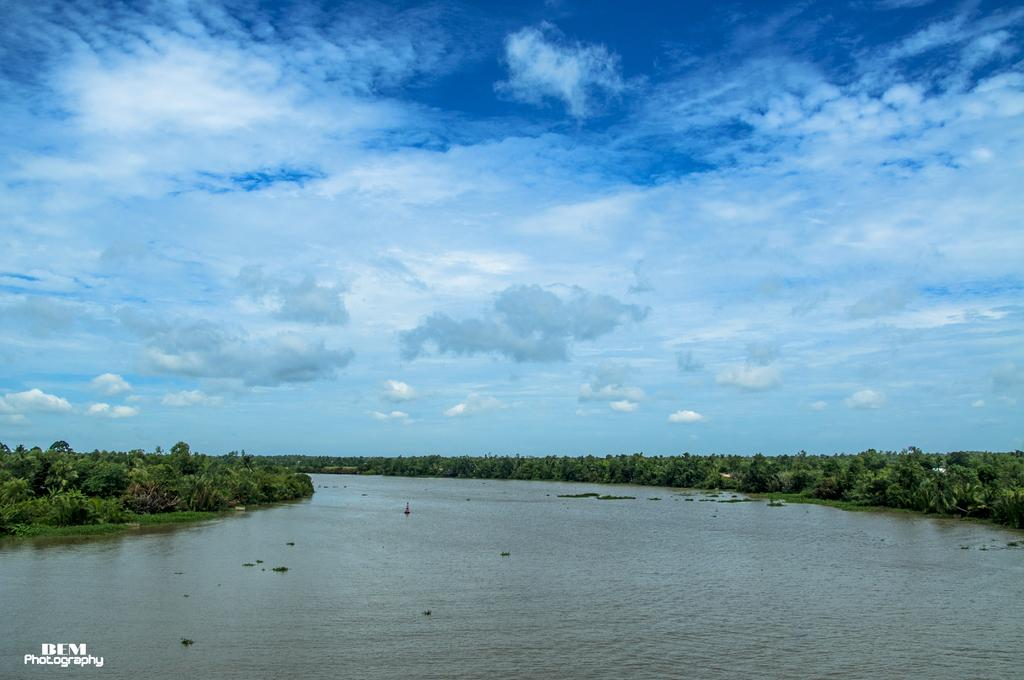What is the main subject in the center of the image? There is water in the center of the image. What can be seen in the background of the image? There are trees and the sky visible in the background of the image. Where is the text located in the image? The text is on the left side of the image. What type of throne is depicted in the image? There is no throne present in the image. 